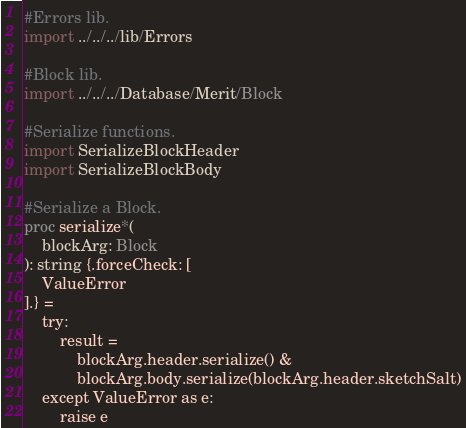Convert code to text. <code><loc_0><loc_0><loc_500><loc_500><_Nim_>#Errors lib.
import ../../../lib/Errors

#Block lib.
import ../../../Database/Merit/Block

#Serialize functions.
import SerializeBlockHeader
import SerializeBlockBody

#Serialize a Block.
proc serialize*(
    blockArg: Block
): string {.forceCheck: [
    ValueError
].} =
    try:
        result =
            blockArg.header.serialize() &
            blockArg.body.serialize(blockArg.header.sketchSalt)
    except ValueError as e:
        raise e
</code> 